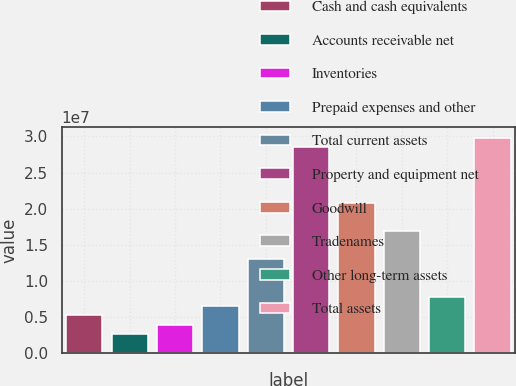<chart> <loc_0><loc_0><loc_500><loc_500><bar_chart><fcel>Cash and cash equivalents<fcel>Accounts receivable net<fcel>Inventories<fcel>Prepaid expenses and other<fcel>Total current assets<fcel>Property and equipment net<fcel>Goodwill<fcel>Tradenames<fcel>Other long-term assets<fcel>Total assets<nl><fcel>5.1897e+06<fcel>2.59497e+06<fcel>3.89234e+06<fcel>6.48707e+06<fcel>1.29739e+07<fcel>2.85423e+07<fcel>2.07581e+07<fcel>1.6866e+07<fcel>7.78444e+06<fcel>2.98397e+07<nl></chart> 